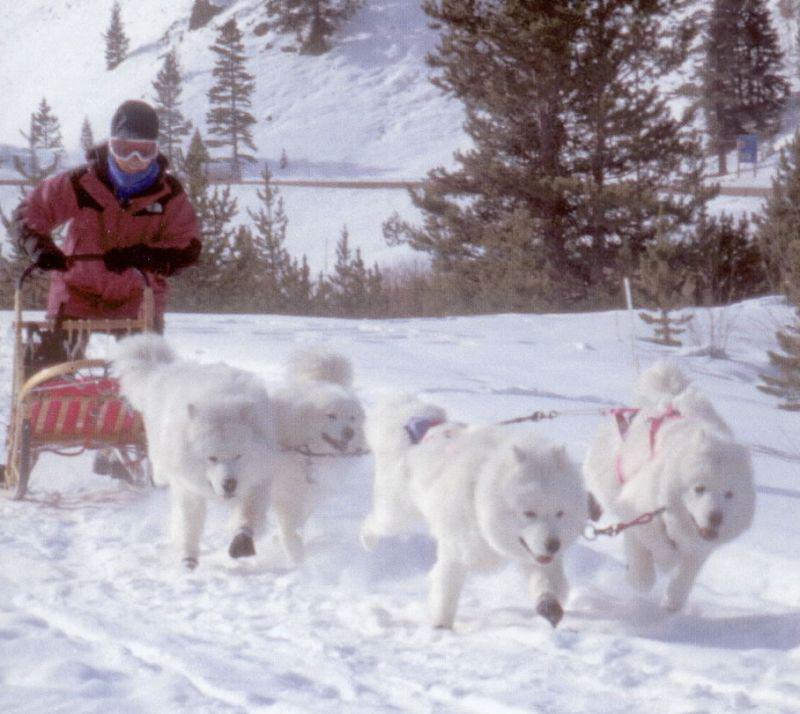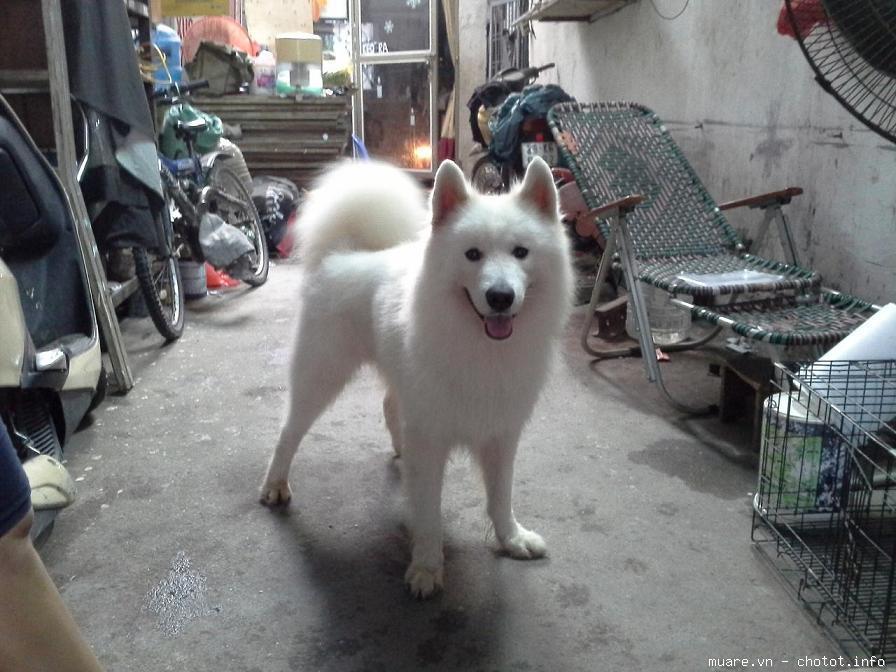The first image is the image on the left, the second image is the image on the right. Given the left and right images, does the statement "An image shows a rider in a sled behind a team of white sled dogs." hold true? Answer yes or no. Yes. The first image is the image on the left, the second image is the image on the right. Analyze the images presented: Is the assertion "A team of dogs is pulling a sled in one of the images." valid? Answer yes or no. Yes. 